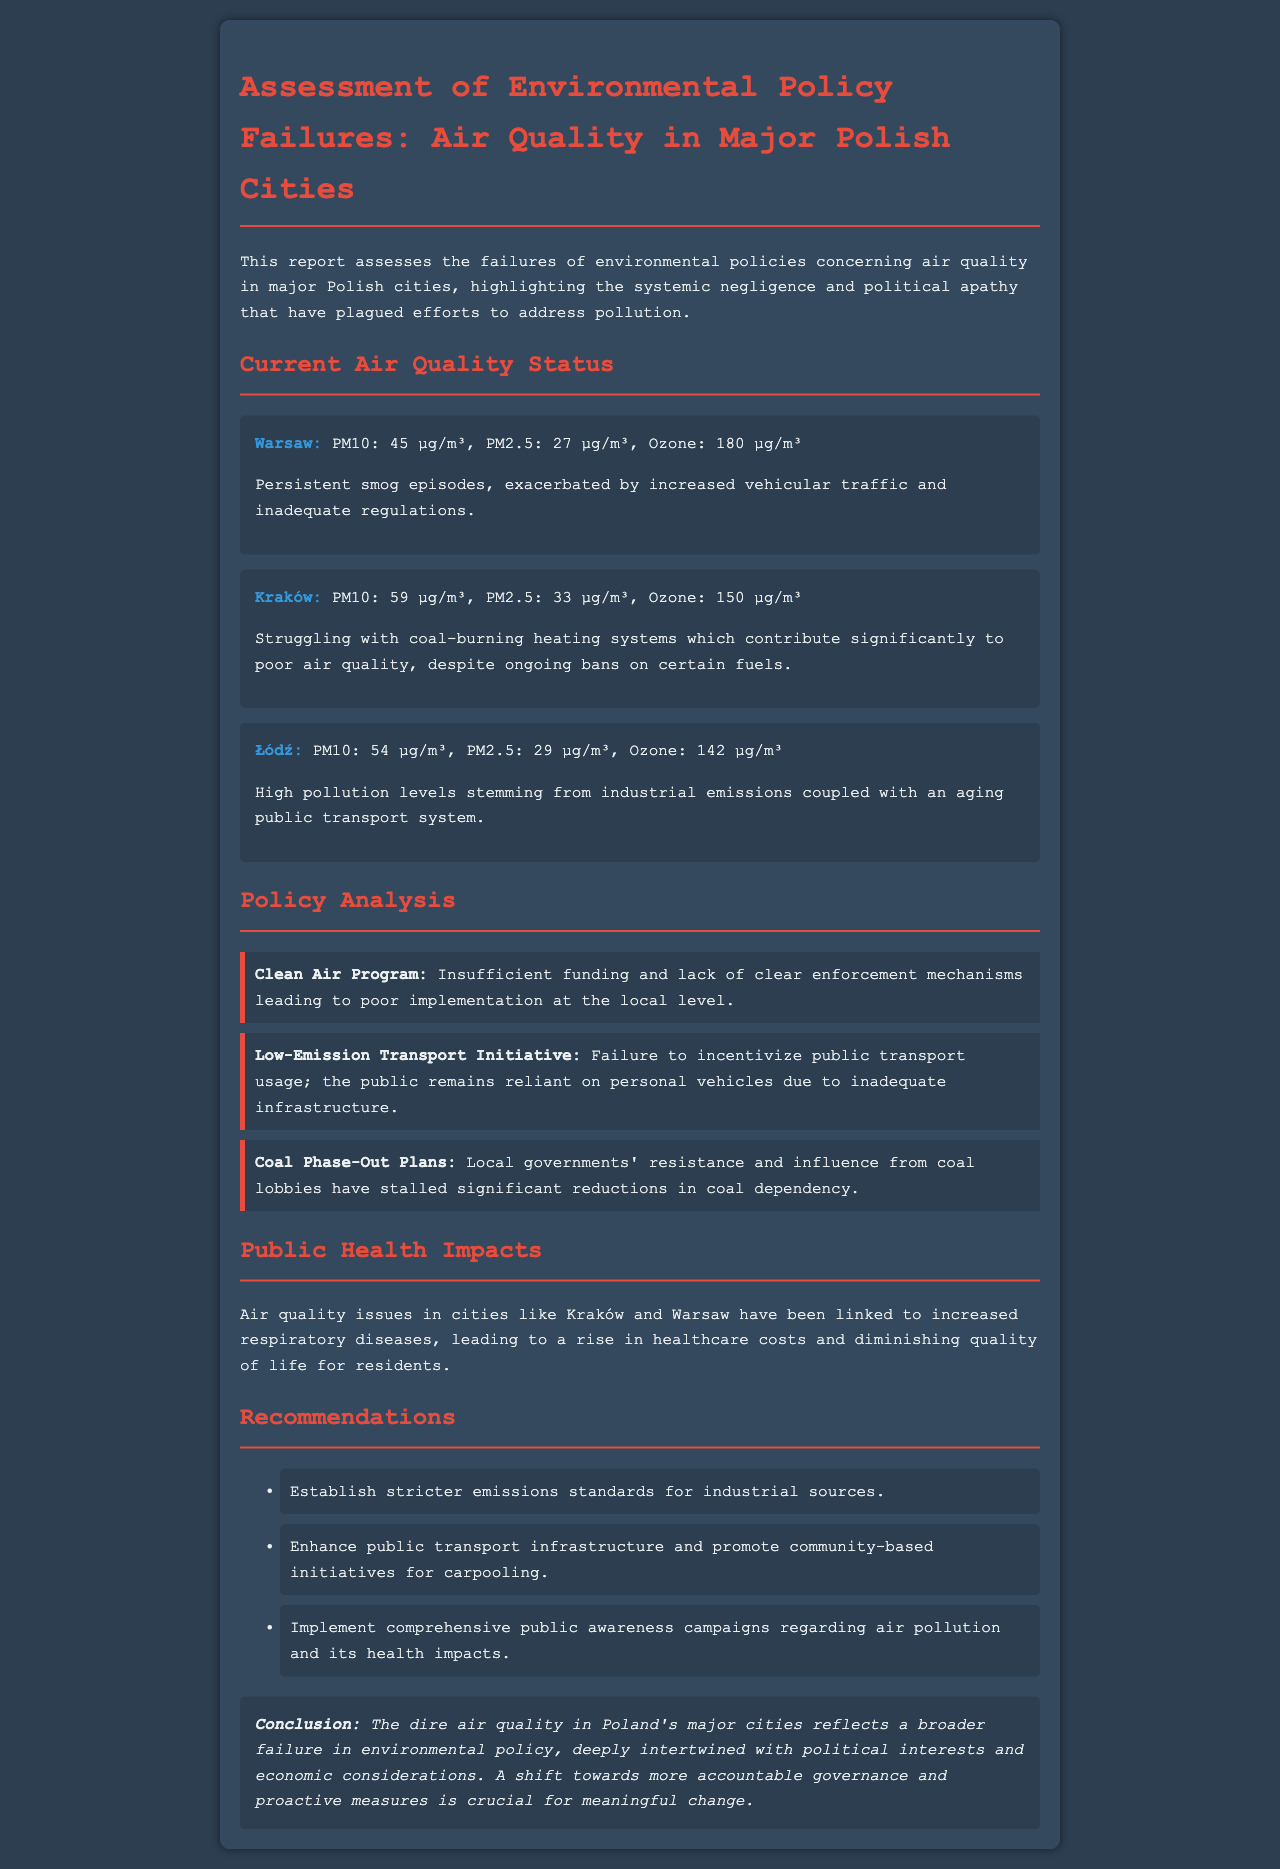What is the PM10 level in Kraków? The PM10 level in Kraków is mentioned as 59 µg/m³ in the report.
Answer: 59 µg/m³ What initiates the persistent smog episodes in Warsaw? The report states that persistent smog episodes are exacerbated by increased vehicular traffic.
Answer: Increased vehicular traffic What are the main contributors to air quality issues in Łódź? The document highlights high pollution levels from industrial emissions and an aging public transport system as contributors in Łódź.
Answer: Industrial emissions and aging public transport system What is the primary issue with the Clean Air Program? According to the report, the primary issue with the Clean Air Program is insufficient funding and lack of clear enforcement mechanisms.
Answer: Insufficient funding and lack of clear enforcement mechanisms How has air quality in major cities affected public health? The document links air quality issues in cities like Kraków and Warsaw to increased respiratory diseases.
Answer: Increased respiratory diseases What is one recommendation for improving public transport? The report recommends enhancing public transport infrastructure as a way to improve public transport.
Answer: Enhance public transport infrastructure What political influence has stalled the Coal Phase-Out Plans? The document indicates that local governments' resistance and influence from coal lobbies have stalled these plans.
Answer: Local governments' resistance and coal lobbies What is the overall conclusion regarding air quality and governance? The conclusion of the report states that the dire air quality reflects a failure in environmental policy intertwined with political interests.
Answer: A failure in environmental policy intertwined with political interests 